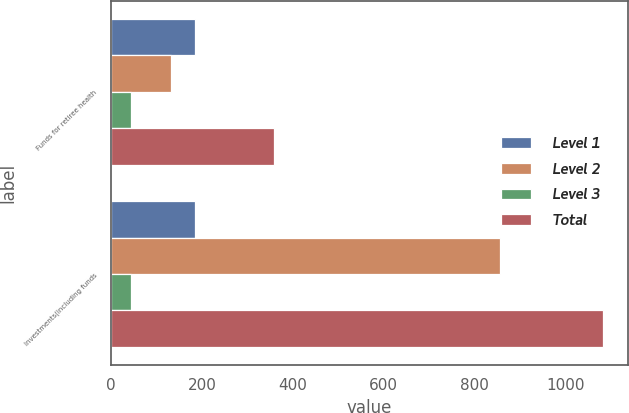Convert chart to OTSL. <chart><loc_0><loc_0><loc_500><loc_500><stacked_bar_chart><ecel><fcel>Funds for retiree health<fcel>Investments(including funds<nl><fcel>Level 1<fcel>184<fcel>184<nl><fcel>Level 2<fcel>131<fcel>856<nl><fcel>Level 3<fcel>43<fcel>43<nl><fcel>Total<fcel>358<fcel>1083<nl></chart> 